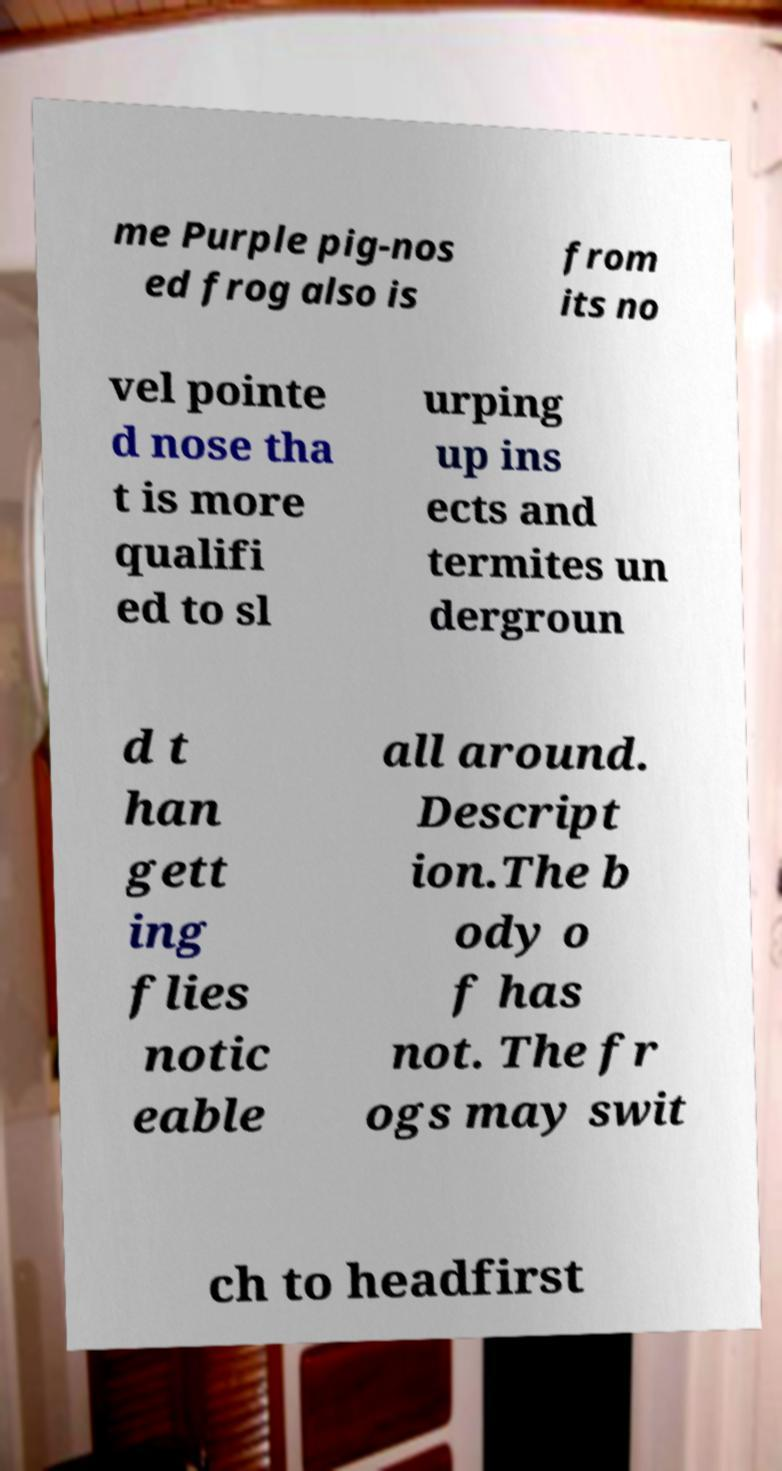I need the written content from this picture converted into text. Can you do that? me Purple pig-nos ed frog also is from its no vel pointe d nose tha t is more qualifi ed to sl urping up ins ects and termites un dergroun d t han gett ing flies notic eable all around. Descript ion.The b ody o f has not. The fr ogs may swit ch to headfirst 